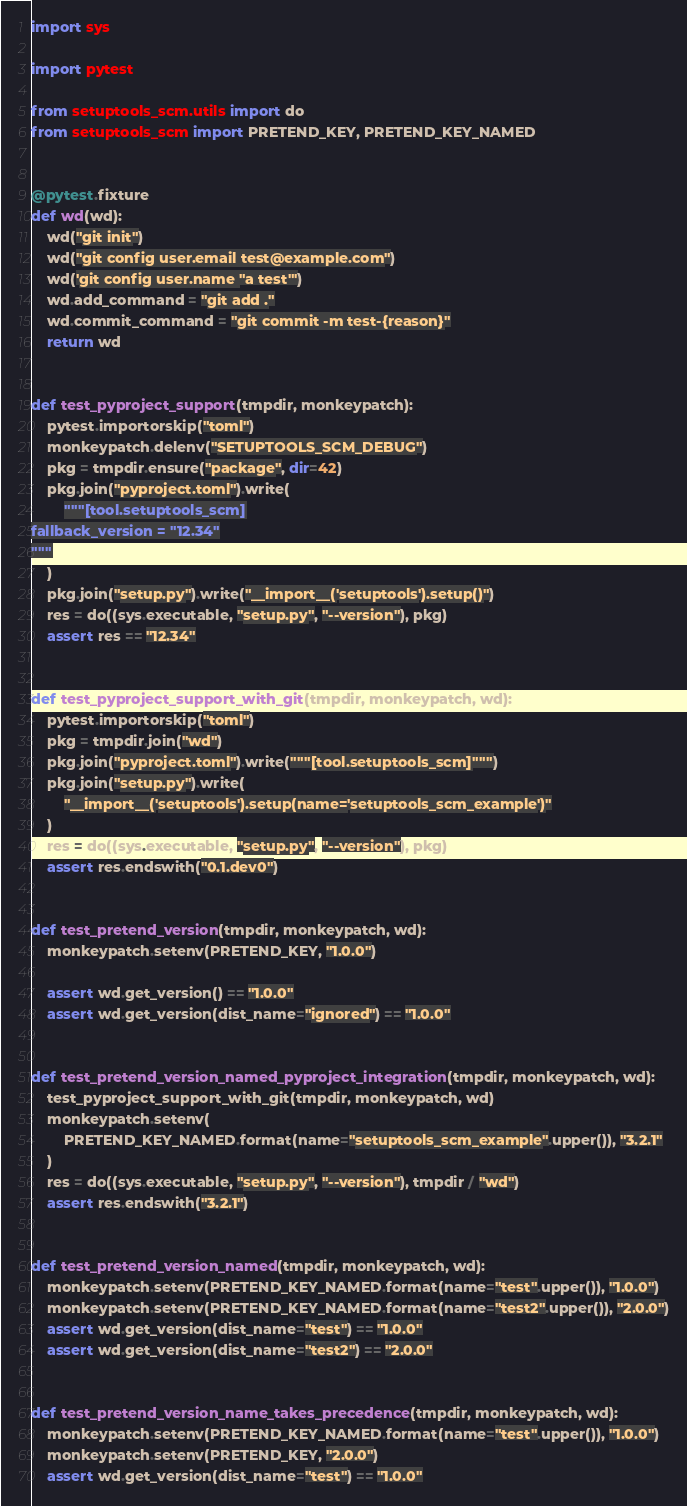Convert code to text. <code><loc_0><loc_0><loc_500><loc_500><_Python_>import sys

import pytest

from setuptools_scm.utils import do
from setuptools_scm import PRETEND_KEY, PRETEND_KEY_NAMED


@pytest.fixture
def wd(wd):
    wd("git init")
    wd("git config user.email test@example.com")
    wd('git config user.name "a test"')
    wd.add_command = "git add ."
    wd.commit_command = "git commit -m test-{reason}"
    return wd


def test_pyproject_support(tmpdir, monkeypatch):
    pytest.importorskip("toml")
    monkeypatch.delenv("SETUPTOOLS_SCM_DEBUG")
    pkg = tmpdir.ensure("package", dir=42)
    pkg.join("pyproject.toml").write(
        """[tool.setuptools_scm]
fallback_version = "12.34"
"""
    )
    pkg.join("setup.py").write("__import__('setuptools').setup()")
    res = do((sys.executable, "setup.py", "--version"), pkg)
    assert res == "12.34"


def test_pyproject_support_with_git(tmpdir, monkeypatch, wd):
    pytest.importorskip("toml")
    pkg = tmpdir.join("wd")
    pkg.join("pyproject.toml").write("""[tool.setuptools_scm]""")
    pkg.join("setup.py").write(
        "__import__('setuptools').setup(name='setuptools_scm_example')"
    )
    res = do((sys.executable, "setup.py", "--version"), pkg)
    assert res.endswith("0.1.dev0")


def test_pretend_version(tmpdir, monkeypatch, wd):
    monkeypatch.setenv(PRETEND_KEY, "1.0.0")

    assert wd.get_version() == "1.0.0"
    assert wd.get_version(dist_name="ignored") == "1.0.0"


def test_pretend_version_named_pyproject_integration(tmpdir, monkeypatch, wd):
    test_pyproject_support_with_git(tmpdir, monkeypatch, wd)
    monkeypatch.setenv(
        PRETEND_KEY_NAMED.format(name="setuptools_scm_example".upper()), "3.2.1"
    )
    res = do((sys.executable, "setup.py", "--version"), tmpdir / "wd")
    assert res.endswith("3.2.1")


def test_pretend_version_named(tmpdir, monkeypatch, wd):
    monkeypatch.setenv(PRETEND_KEY_NAMED.format(name="test".upper()), "1.0.0")
    monkeypatch.setenv(PRETEND_KEY_NAMED.format(name="test2".upper()), "2.0.0")
    assert wd.get_version(dist_name="test") == "1.0.0"
    assert wd.get_version(dist_name="test2") == "2.0.0"


def test_pretend_version_name_takes_precedence(tmpdir, monkeypatch, wd):
    monkeypatch.setenv(PRETEND_KEY_NAMED.format(name="test".upper()), "1.0.0")
    monkeypatch.setenv(PRETEND_KEY, "2.0.0")
    assert wd.get_version(dist_name="test") == "1.0.0"
</code> 